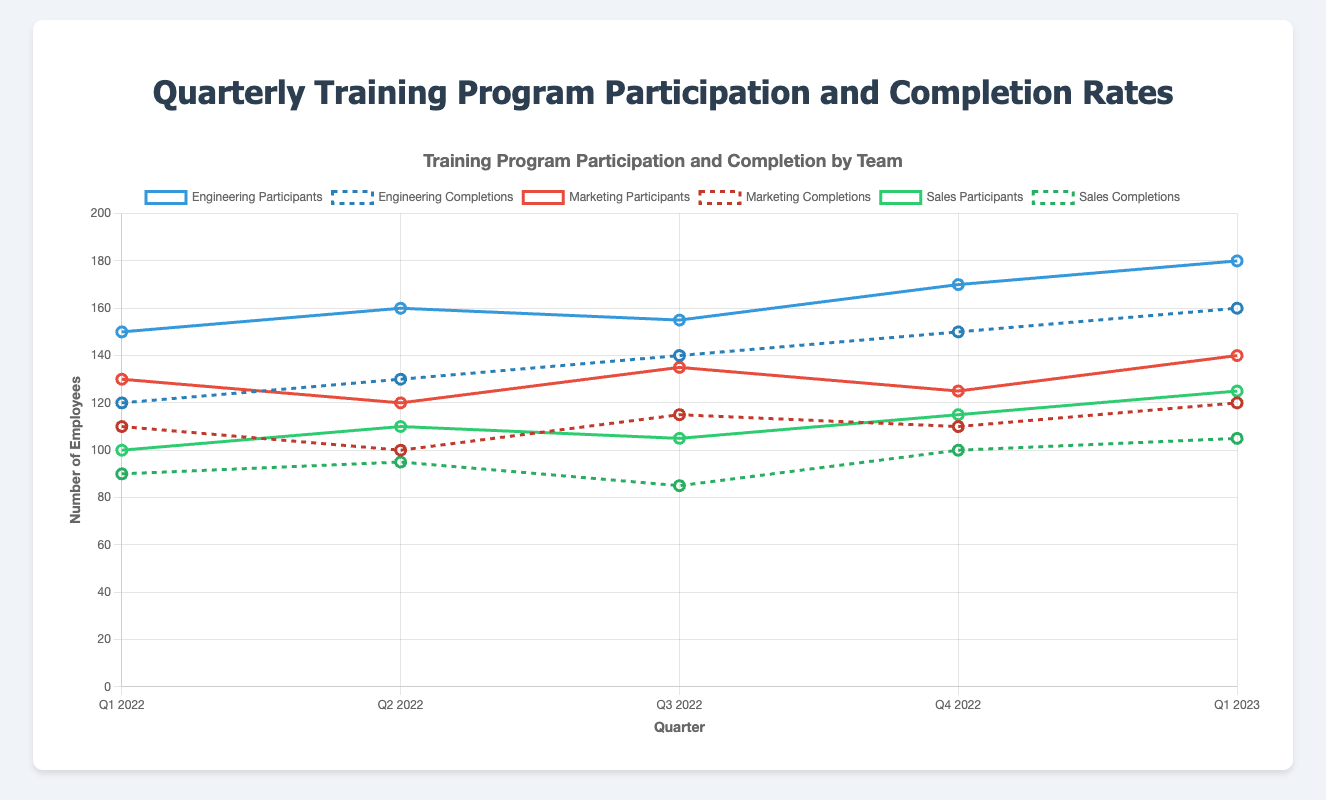What is the overall trend in participation rates for the Engineering team from Q1 2022 to Q1 2023? The Engineering team's participation rates increased over the quarters. In Q1 2022, there were 150 participants, which increased to 160 in Q2 2022, 155 in Q3 2022, 170 in Q4 2022, and reached 180 in Q1 2023.
Answer: Increasing How does the Q4 2022 participant count for the Marketing team compare to the Sales team? In Q4 2022, the Marketing team had 125 participants, whereas the Sales team had 115 participants. The Marketing team had more participants than the Sales team.
Answer: Marketing What is the total number of completions for the Sales team across all quarters? To find the total completions for the Sales team, sum up the completions for each quarter: 90 (Q1 2022) + 95 (Q2 2022) + 85 (Q3 2022) + 100 (Q4 2022) + 105 (Q1 2023) = 475 completions.
Answer: 475 Which quarter had the highest completion rate for the Engineering team? The completion rates are calculated as the ratio of completions to participants for each quarter: Q1 2022: 120/150 = 0.8, Q2 2022: 130/160 = 0.8125, Q3 2022: 140/155 = 0.903, Q4 2022: 150/170 = 0.882, Q1 2023: 160/180 = 0.889. Q3 2022 has the highest completion rate of approximately 0.903.
Answer: Q3 2022 What is the difference in completion counts between Engineering and Marketing teams in Q1 2023? In Q1 2023, the Engineering team had 160 completions, while the Marketing team had 120 completions. The difference is 160 - 120 = 40 completions.
Answer: 40 Which team showed the largest increase in participant numbers from Q1 2022 to Q1 2023? The differences in participant numbers from Q1 2022 to Q1 2023 are Engineering: 180 - 150 = 30, Marketing: 140 - 130 = 10, Sales: 125 - 100 = 25. The Engineering team showed the largest increase of 30 participants.
Answer: Engineering What color lines represent the Sales team's participants and completions on the chart? The line color for Sales team participants is green, and the line color for completions is a dashed green.
Answer: Green What is the average number of participants for the Marketing team across all quarters? The total number of participants for the Marketing team across all quarters is 130 (Q1 2022) + 120 (Q2 2022) + 135 (Q3 2022) + 125 (Q4 2022) + 140 (Q1 2023) = 650. There are 5 quarters, so the average is 650/5 = 130 participants.
Answer: 130 